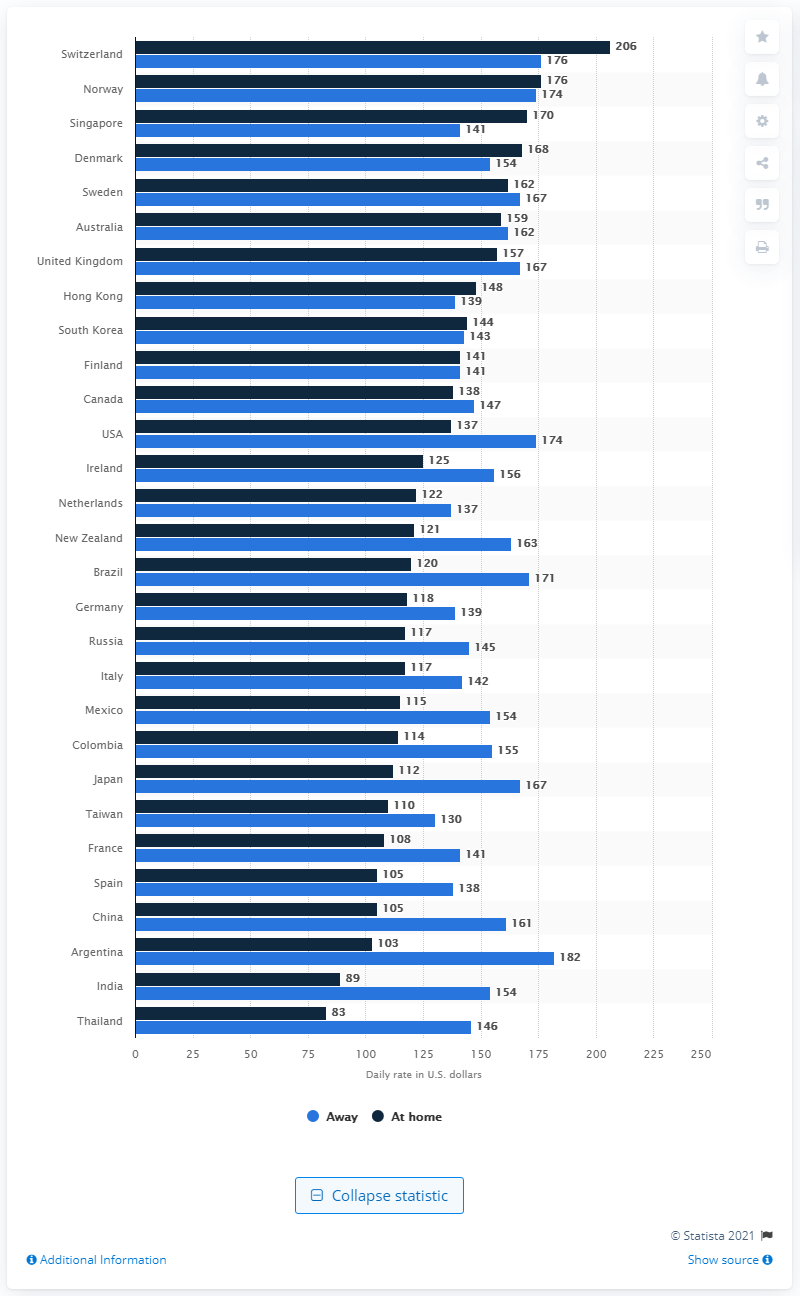Mention a couple of crucial points in this snapshot. In 2014, the average price per night for a hotel room in Switzerland was 206. 